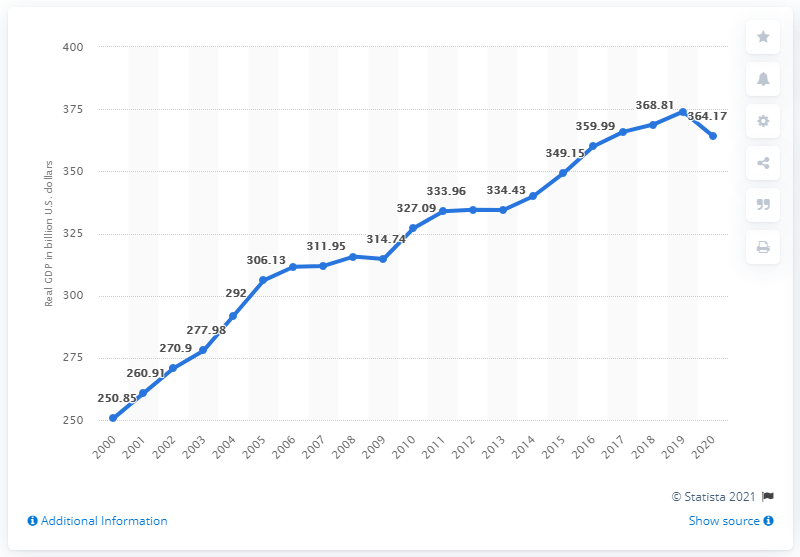Give some essential details in this illustration. The Gross Domestic Product (GDP) of Maryland in 2020 was 364.17 billion dollars. The previous year, the Gross Domestic Product (GDP) of Maryland was 374.04.. 